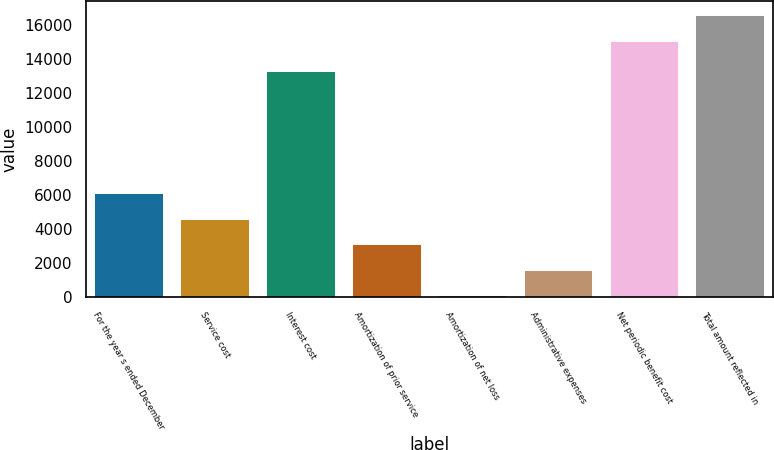<chart> <loc_0><loc_0><loc_500><loc_500><bar_chart><fcel>For the year s ended December<fcel>Service cost<fcel>Interest cost<fcel>Amortization of prior service<fcel>Amortization of net loss<fcel>Administrative expenses<fcel>Net periodic benefit cost<fcel>Total amount reflected in<nl><fcel>6087.8<fcel>4591.1<fcel>13258<fcel>3094.4<fcel>101<fcel>1597.7<fcel>15068<fcel>16564.7<nl></chart> 